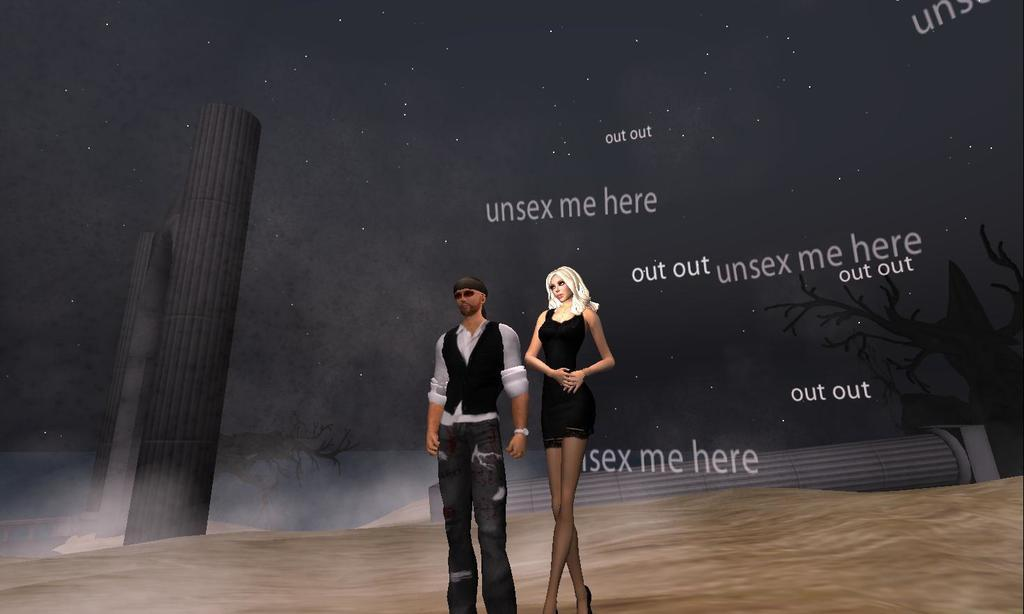What type of picture is the image? The image is an animated picture. Can you describe the man in the image? The man in the image is wearing a black coat. Who else is present in the image? There is a beautiful girl in the image. What is the girl wearing? The girl is wearing a black dress. What type of pies can be seen in the image? There are no pies present in the image. What answer does the girl provide in the image? There is no indication in the image that the girl is providing an answer to a question. 